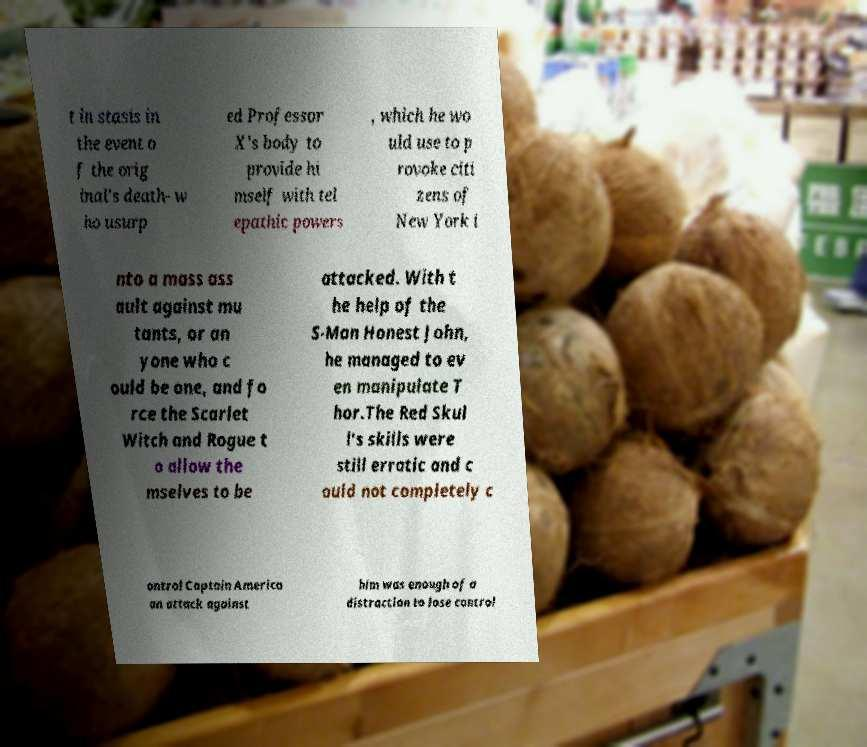Can you read and provide the text displayed in the image?This photo seems to have some interesting text. Can you extract and type it out for me? t in stasis in the event o f the orig inal's death- w ho usurp ed Professor X's body to provide hi mself with tel epathic powers , which he wo uld use to p rovoke citi zens of New York i nto a mass ass ault against mu tants, or an yone who c ould be one, and fo rce the Scarlet Witch and Rogue t o allow the mselves to be attacked. With t he help of the S-Man Honest John, he managed to ev en manipulate T hor.The Red Skul l's skills were still erratic and c ould not completely c ontrol Captain America an attack against him was enough of a distraction to lose control 